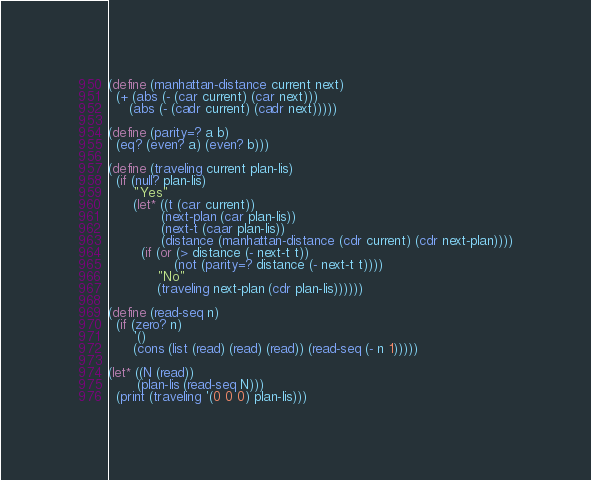Convert code to text. <code><loc_0><loc_0><loc_500><loc_500><_Scheme_>(define (manhattan-distance current next)
  (+ (abs (- (car current) (car next)))
     (abs (- (cadr current) (cadr next)))))

(define (parity=? a b)
  (eq? (even? a) (even? b)))

(define (traveling current plan-lis)
  (if (null? plan-lis)
      "Yes"
      (let* ((t (car current))
             (next-plan (car plan-lis))
             (next-t (caar plan-lis))
             (distance (manhattan-distance (cdr current) (cdr next-plan))))
        (if (or (> distance (- next-t t))
                (not (parity=? distance (- next-t t))))
            "No"
            (traveling next-plan (cdr plan-lis))))))

(define (read-seq n)
  (if (zero? n)
      '()
      (cons (list (read) (read) (read)) (read-seq (- n 1)))))

(let* ((N (read))
       (plan-lis (read-seq N)))
  (print (traveling '(0 0 0) plan-lis)))
</code> 